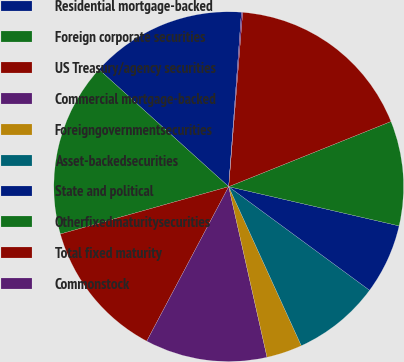<chart> <loc_0><loc_0><loc_500><loc_500><pie_chart><fcel>Residential mortgage-backed<fcel>Foreign corporate securities<fcel>US Treasury/agency securities<fcel>Commercial mortgage-backed<fcel>Foreigngovernmentsecurities<fcel>Asset-backedsecurities<fcel>State and political<fcel>Otherfixedmaturitysecurities<fcel>Total fixed maturity<fcel>Commonstock<nl><fcel>14.47%<fcel>16.06%<fcel>12.87%<fcel>11.28%<fcel>3.3%<fcel>8.09%<fcel>6.49%<fcel>9.68%<fcel>17.65%<fcel>0.11%<nl></chart> 